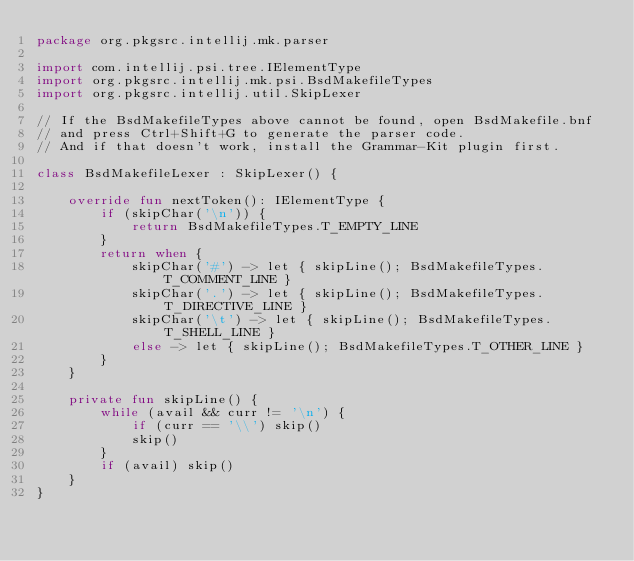Convert code to text. <code><loc_0><loc_0><loc_500><loc_500><_Kotlin_>package org.pkgsrc.intellij.mk.parser

import com.intellij.psi.tree.IElementType
import org.pkgsrc.intellij.mk.psi.BsdMakefileTypes
import org.pkgsrc.intellij.util.SkipLexer

// If the BsdMakefileTypes above cannot be found, open BsdMakefile.bnf
// and press Ctrl+Shift+G to generate the parser code.
// And if that doesn't work, install the Grammar-Kit plugin first.

class BsdMakefileLexer : SkipLexer() {

    override fun nextToken(): IElementType {
        if (skipChar('\n')) {
            return BsdMakefileTypes.T_EMPTY_LINE
        }
        return when {
            skipChar('#') -> let { skipLine(); BsdMakefileTypes.T_COMMENT_LINE }
            skipChar('.') -> let { skipLine(); BsdMakefileTypes.T_DIRECTIVE_LINE }
            skipChar('\t') -> let { skipLine(); BsdMakefileTypes.T_SHELL_LINE }
            else -> let { skipLine(); BsdMakefileTypes.T_OTHER_LINE }
        }
    }

    private fun skipLine() {
        while (avail && curr != '\n') {
            if (curr == '\\') skip()
            skip()
        }
        if (avail) skip()
    }
}
</code> 